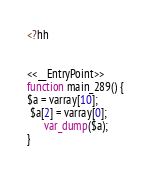Convert code to text. <code><loc_0><loc_0><loc_500><loc_500><_PHP_><?hh


<<__EntryPoint>>
function main_289() {
$a = varray[10];
 $a[2] = varray[0];
      var_dump($a);
}
</code> 